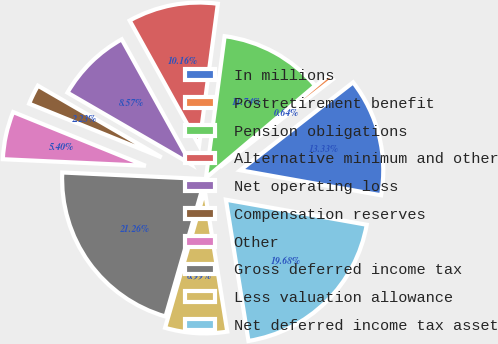<chart> <loc_0><loc_0><loc_500><loc_500><pie_chart><fcel>In millions<fcel>Postretirement benefit<fcel>Pension obligations<fcel>Alternative minimum and other<fcel>Net operating loss<fcel>Compensation reserves<fcel>Other<fcel>Gross deferred income tax<fcel>Less valuation allowance<fcel>Net deferred income tax asset<nl><fcel>13.33%<fcel>0.64%<fcel>11.74%<fcel>10.16%<fcel>8.57%<fcel>2.23%<fcel>5.4%<fcel>21.26%<fcel>6.99%<fcel>19.68%<nl></chart> 